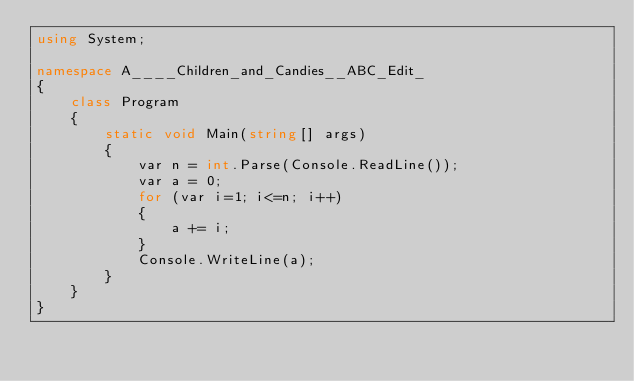Convert code to text. <code><loc_0><loc_0><loc_500><loc_500><_C#_>using System;

namespace A____Children_and_Candies__ABC_Edit_
{
    class Program
    {
        static void Main(string[] args)
        {
            var n = int.Parse(Console.ReadLine());
            var a = 0;
            for (var i=1; i<=n; i++)
            {
                a += i;
            }
            Console.WriteLine(a);
        }
    }
}</code> 